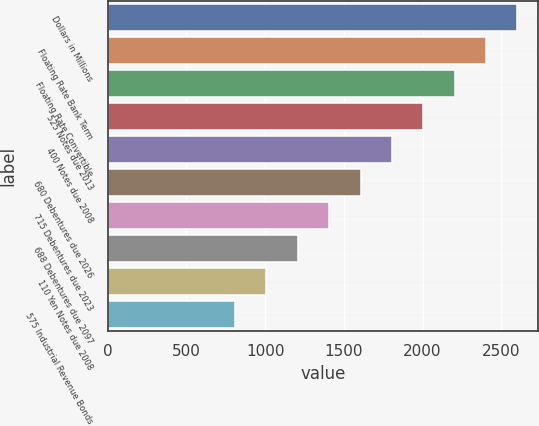<chart> <loc_0><loc_0><loc_500><loc_500><bar_chart><fcel>Dollars in Millions<fcel>Floating Rate Bank Term<fcel>Floating Rate Convertible<fcel>525 Notes due 2013<fcel>400 Notes due 2008<fcel>680 Debentures due 2026<fcel>715 Debentures due 2023<fcel>688 Debentures due 2097<fcel>110 Yen Notes due 2008<fcel>575 Industrial Revenue Bonds<nl><fcel>2603.2<fcel>2403.8<fcel>2204.4<fcel>2005<fcel>1805.6<fcel>1606.2<fcel>1406.8<fcel>1207.4<fcel>1008<fcel>808.6<nl></chart> 